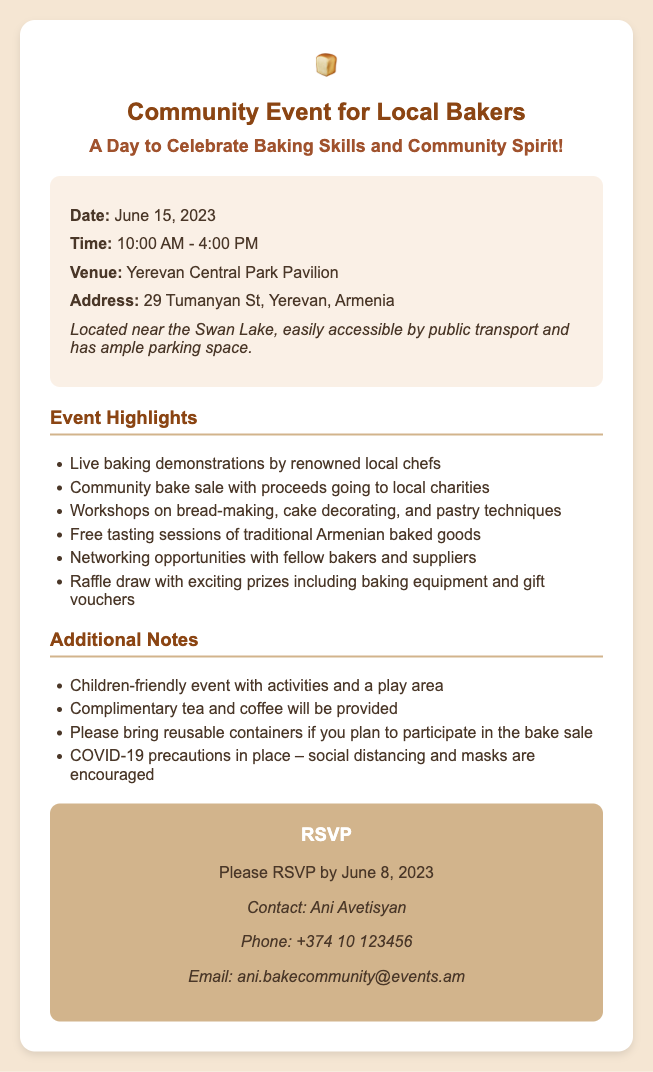What is the date of the event? The date of the event is mentioned clearly in the document as June 15, 2023.
Answer: June 15, 2023 What time does the event start? The event's starting time is listed in the document as 10:00 AM.
Answer: 10:00 AM Where is the venue located? The venue for the event is specified in the document as Yerevan Central Park Pavilion.
Answer: Yerevan Central Park Pavilion Who should I contact for RSVP? The contact person for RSVP is mentioned in the document as Ani Avetisyan.
Answer: Ani Avetisyan What is the RSVP deadline? The document states the RSVP deadline as June 8, 2023.
Answer: June 8, 2023 What activity will have live demonstrations? The document highlights that live baking demonstrations will be conducted by renowned local chefs.
Answer: Baking demonstrations Are children allowed at the event? The document indicates that it is a children-friendly event.
Answer: Yes What will be provided complimentary during the event? The document mentions complimentary tea and coffee will be provided.
Answer: Tea and coffee What is encouraged due to COVID-19? The document suggests that social distancing and masks are encouraged as a COVID-19 precaution.
Answer: Social distancing and masks 